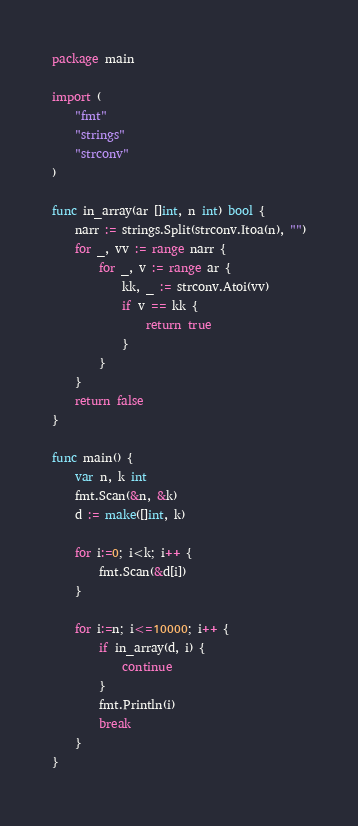Convert code to text. <code><loc_0><loc_0><loc_500><loc_500><_Go_>package main

import (
	"fmt"
	"strings"
	"strconv"
)

func in_array(ar []int, n int) bool {
	narr := strings.Split(strconv.Itoa(n), "")
	for _, vv := range narr {
		for _, v := range ar {
			kk, _ := strconv.Atoi(vv)
			if v == kk {
				return true
			}
		}
	}
	return false
}

func main() {
	var n, k int
	fmt.Scan(&n, &k)
	d := make([]int, k)

	for i:=0; i<k; i++ {
		fmt.Scan(&d[i])
	}

	for i:=n; i<=10000; i++ {
		if in_array(d, i) {
			continue
		}
		fmt.Println(i)
		break
	}
}</code> 